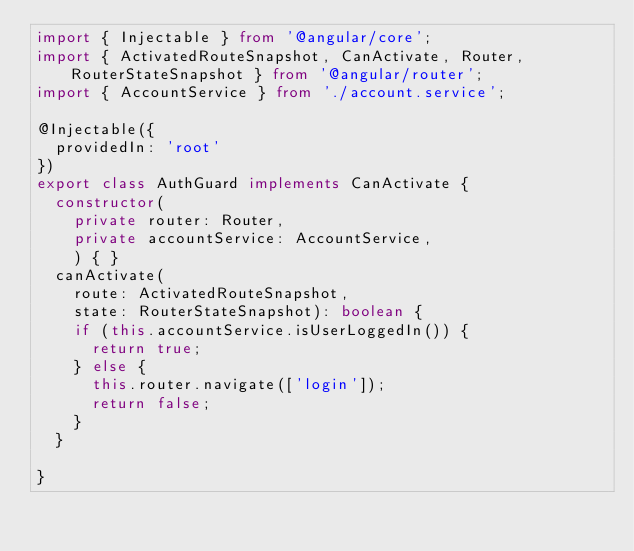<code> <loc_0><loc_0><loc_500><loc_500><_TypeScript_>import { Injectable } from '@angular/core';
import { ActivatedRouteSnapshot, CanActivate, Router, RouterStateSnapshot } from '@angular/router';
import { AccountService } from './account.service';

@Injectable({
  providedIn: 'root'
})
export class AuthGuard implements CanActivate {
  constructor(
    private router: Router,
    private accountService: AccountService,
    ) { }
  canActivate(
    route: ActivatedRouteSnapshot,
    state: RouterStateSnapshot): boolean {
    if (this.accountService.isUserLoggedIn()) {
      return true;
    } else {
      this.router.navigate(['login']);
      return false;
    }
  }

}
</code> 